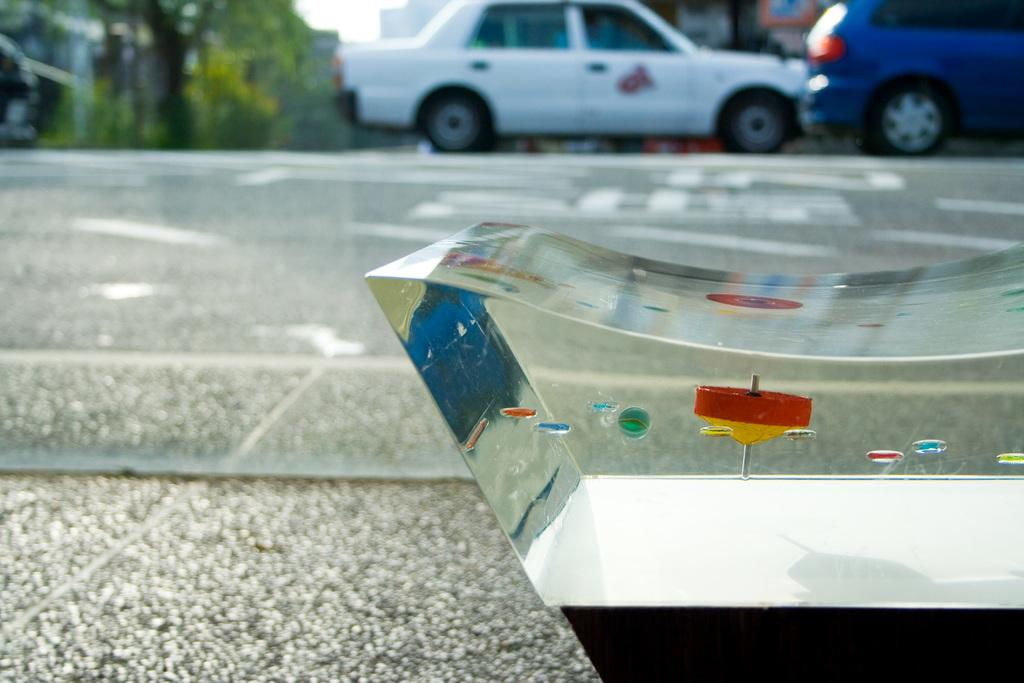What is the main object in the center of the image? There is a glass in the center of the image. Where is the glass located? The glass is on the road. What can be seen in the background of the image? There are vehicles, buildings, trees, and the sky visible in the background of the image. What does the glass say when it opens its mouth in the image? There is no indication that the glass has a mouth or can speak in the image. 